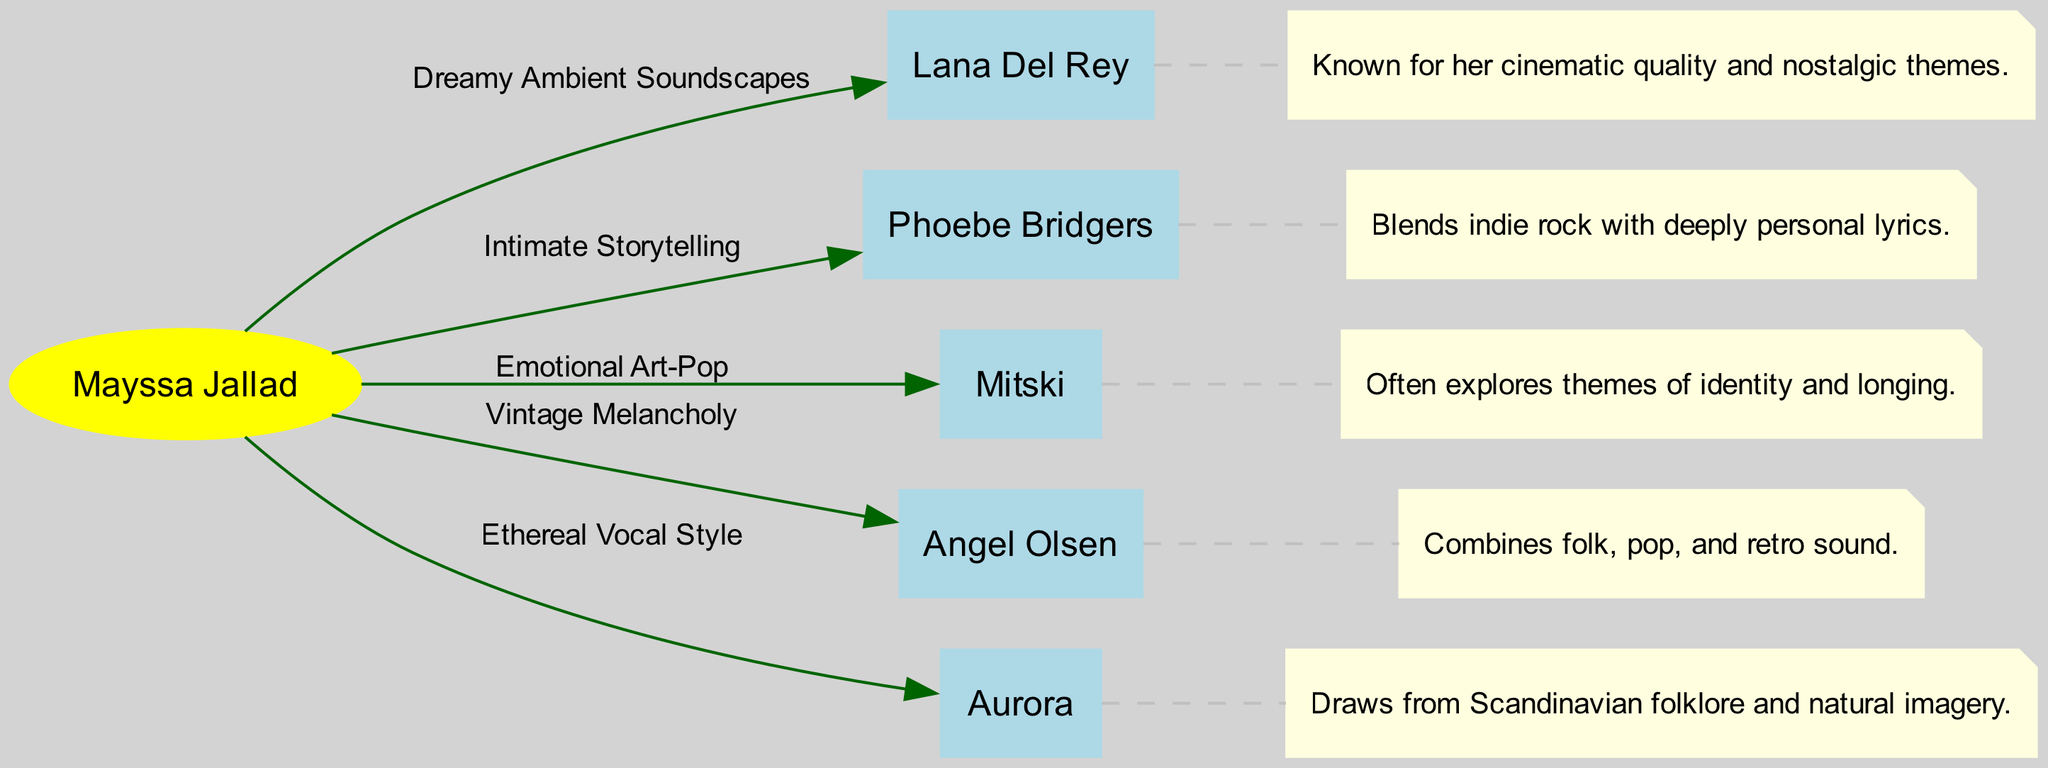What is the number of nodes in the diagram? The diagram lists six nodes: Mayssa Jallad, Lana Del Rey, Phoebe Bridgers, Mitski, Angel Olsen, and Aurora. Therefore, counting these gives a total of six nodes.
Answer: 6 Which artist is connected to Mayssa Jallad by "Ethereal Vocal Style"? Looking at the edges in the diagram, the edge connecting Mayssa Jallad to Aurora is labeled "Ethereal Vocal Style," indicating this specific relationship.
Answer: Aurora What type of soundscapes does Mayssa Jallad share with Lana Del Rey? The connection between Mayssa Jallad and Lana Del Rey is described as "Dreamy Ambient Soundscapes," indicating the type of sound they share.
Answer: Dreamy Ambient Soundscapes Which artist explores themes of identity and longing? The diagram annotates Mitski as often exploring themes of identity and longing, making her the artist associated with these themes.
Answer: Mitski What color represents the node for Mayssa Jallad? In the diagram, Mayssa Jallad's node is represented in yellow, which specifically indicates the different styling for her compared to the other nodes.
Answer: Yellow How many connections does Mayssa Jallad have in total? By counting the edges connected to Mayssa Jallad, we can see five edges leading to Lana Del Rey, Phoebe Bridgers, Mitski, Angel Olsen, and Aurora, confirming her total connections.
Answer: 5 Which artist has a vintage melancholy style? The annotation linked to Angel Olsen describes her style as combining "folk, pop, and retro sound," which aligns with the term vintage melancholy.
Answer: Angel Olsen What is the main theme of Phoebe Bridgers' music according to the diagram? The annotation for Phoebe Bridgers states that she blends indie rock with deeply personal lyrics, highlighting her main theme in music.
Answer: Deeply personal lyrics 